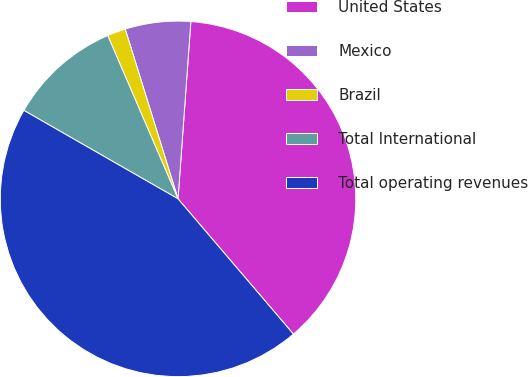<chart> <loc_0><loc_0><loc_500><loc_500><pie_chart><fcel>United States<fcel>Mexico<fcel>Brazil<fcel>Total International<fcel>Total operating revenues<nl><fcel>37.61%<fcel>5.95%<fcel>1.67%<fcel>10.24%<fcel>44.53%<nl></chart> 